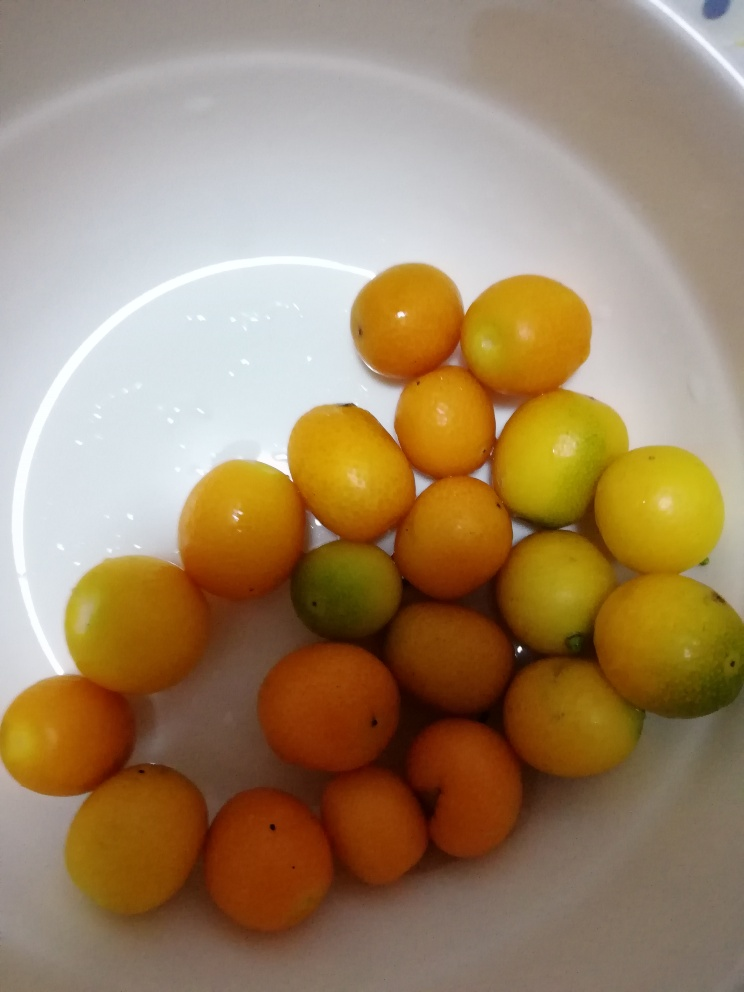Can you tell me what kind of fruits these are and if they are all the same type? These are citrus fruits, likely variations of kumquats or small oranges. They are not all the same type, as indicated by the subtle differences in color and size which suggest they may be different varieties or at various stages of ripeness. 